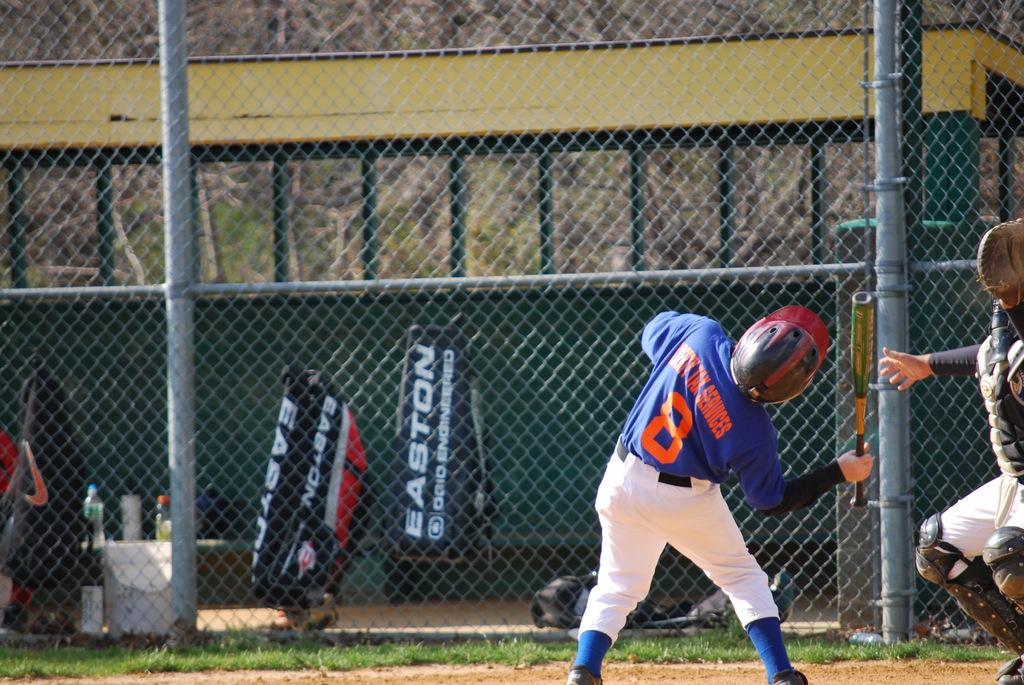<image>
Describe the image concisely. A baseball player with the number 8 stands on a field 